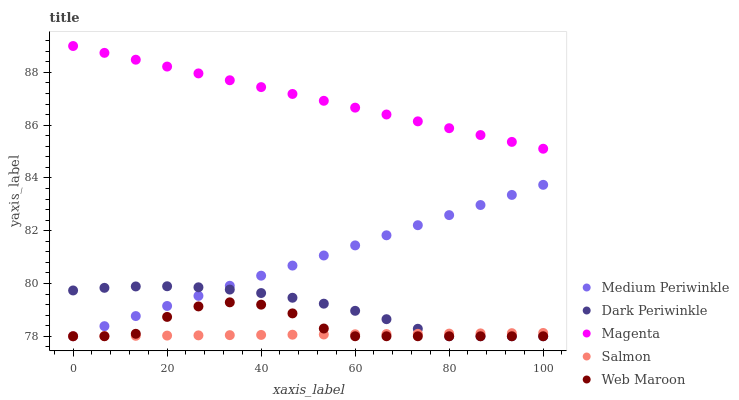Does Salmon have the minimum area under the curve?
Answer yes or no. Yes. Does Magenta have the maximum area under the curve?
Answer yes or no. Yes. Does Medium Periwinkle have the minimum area under the curve?
Answer yes or no. No. Does Medium Periwinkle have the maximum area under the curve?
Answer yes or no. No. Is Medium Periwinkle the smoothest?
Answer yes or no. Yes. Is Web Maroon the roughest?
Answer yes or no. Yes. Is Magenta the smoothest?
Answer yes or no. No. Is Magenta the roughest?
Answer yes or no. No. Does Salmon have the lowest value?
Answer yes or no. Yes. Does Magenta have the lowest value?
Answer yes or no. No. Does Magenta have the highest value?
Answer yes or no. Yes. Does Medium Periwinkle have the highest value?
Answer yes or no. No. Is Medium Periwinkle less than Magenta?
Answer yes or no. Yes. Is Magenta greater than Web Maroon?
Answer yes or no. Yes. Does Dark Periwinkle intersect Medium Periwinkle?
Answer yes or no. Yes. Is Dark Periwinkle less than Medium Periwinkle?
Answer yes or no. No. Is Dark Periwinkle greater than Medium Periwinkle?
Answer yes or no. No. Does Medium Periwinkle intersect Magenta?
Answer yes or no. No. 